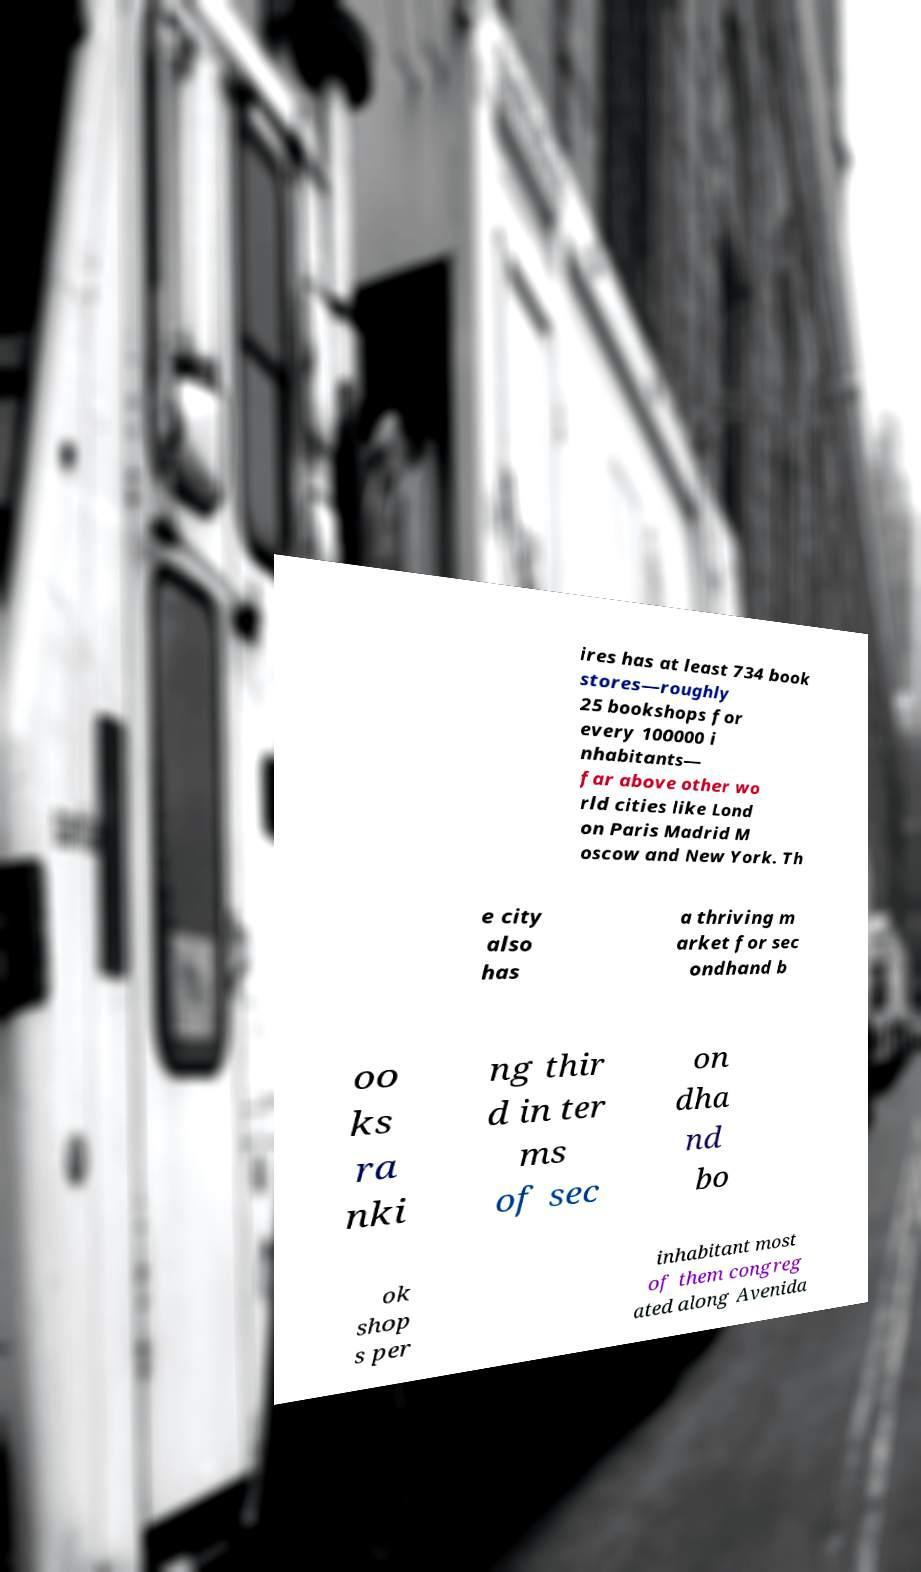For documentation purposes, I need the text within this image transcribed. Could you provide that? ires has at least 734 book stores—roughly 25 bookshops for every 100000 i nhabitants— far above other wo rld cities like Lond on Paris Madrid M oscow and New York. Th e city also has a thriving m arket for sec ondhand b oo ks ra nki ng thir d in ter ms of sec on dha nd bo ok shop s per inhabitant most of them congreg ated along Avenida 